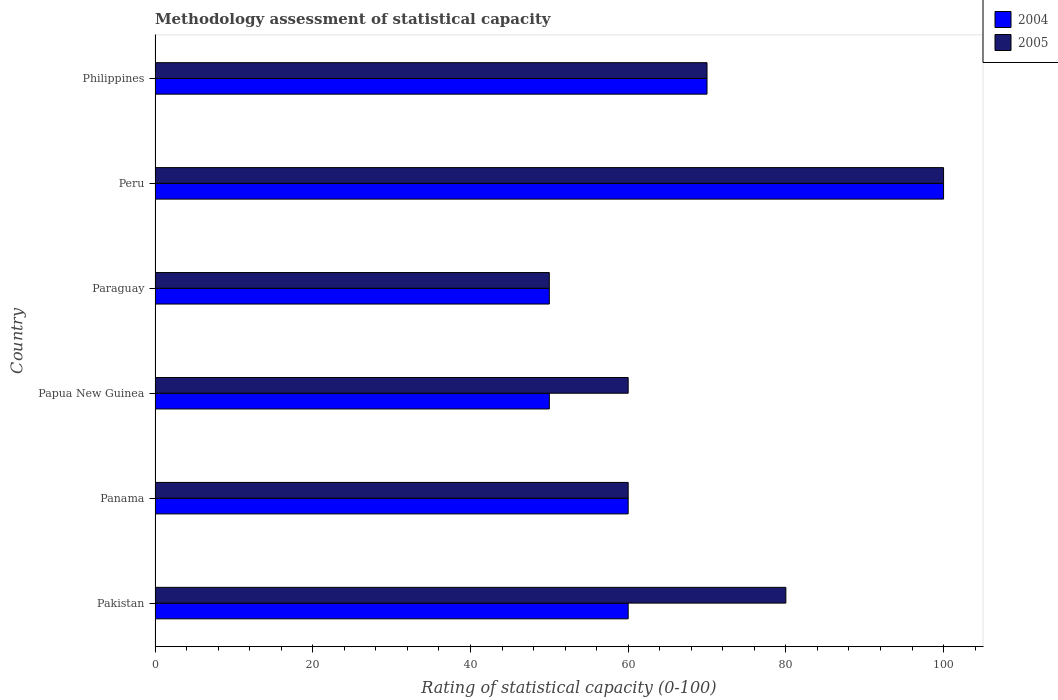Are the number of bars per tick equal to the number of legend labels?
Your answer should be very brief. Yes. What is the label of the 5th group of bars from the top?
Ensure brevity in your answer.  Panama. Across all countries, what is the minimum rating of statistical capacity in 2004?
Keep it short and to the point. 50. In which country was the rating of statistical capacity in 2005 minimum?
Offer a very short reply. Paraguay. What is the total rating of statistical capacity in 2004 in the graph?
Your response must be concise. 390. What is the difference between the rating of statistical capacity in 2004 in Pakistan and that in Papua New Guinea?
Give a very brief answer. 10. What is the difference between the rating of statistical capacity in 2005 in Panama and the rating of statistical capacity in 2004 in Pakistan?
Offer a very short reply. 0. What is the average rating of statistical capacity in 2005 per country?
Give a very brief answer. 70. In how many countries, is the rating of statistical capacity in 2004 greater than 36 ?
Offer a very short reply. 6. What is the ratio of the rating of statistical capacity in 2005 in Pakistan to that in Papua New Guinea?
Your answer should be very brief. 1.33. Is the rating of statistical capacity in 2004 in Panama less than that in Peru?
Offer a terse response. Yes. Is the difference between the rating of statistical capacity in 2004 in Panama and Papua New Guinea greater than the difference between the rating of statistical capacity in 2005 in Panama and Papua New Guinea?
Offer a terse response. Yes. What does the 1st bar from the top in Peru represents?
Make the answer very short. 2005. Are all the bars in the graph horizontal?
Keep it short and to the point. Yes. How many countries are there in the graph?
Ensure brevity in your answer.  6. Are the values on the major ticks of X-axis written in scientific E-notation?
Your answer should be very brief. No. How are the legend labels stacked?
Give a very brief answer. Vertical. What is the title of the graph?
Give a very brief answer. Methodology assessment of statistical capacity. Does "2003" appear as one of the legend labels in the graph?
Your answer should be compact. No. What is the label or title of the X-axis?
Offer a terse response. Rating of statistical capacity (0-100). What is the Rating of statistical capacity (0-100) of 2005 in Pakistan?
Ensure brevity in your answer.  80. What is the Rating of statistical capacity (0-100) of 2005 in Panama?
Offer a very short reply. 60. What is the Rating of statistical capacity (0-100) of 2005 in Papua New Guinea?
Provide a succinct answer. 60. What is the Rating of statistical capacity (0-100) in 2004 in Paraguay?
Keep it short and to the point. 50. What is the Rating of statistical capacity (0-100) in 2005 in Paraguay?
Your response must be concise. 50. What is the Rating of statistical capacity (0-100) in 2005 in Peru?
Your answer should be very brief. 100. What is the Rating of statistical capacity (0-100) of 2005 in Philippines?
Provide a succinct answer. 70. Across all countries, what is the maximum Rating of statistical capacity (0-100) in 2004?
Provide a succinct answer. 100. Across all countries, what is the maximum Rating of statistical capacity (0-100) of 2005?
Ensure brevity in your answer.  100. Across all countries, what is the minimum Rating of statistical capacity (0-100) of 2004?
Make the answer very short. 50. What is the total Rating of statistical capacity (0-100) in 2004 in the graph?
Your answer should be compact. 390. What is the total Rating of statistical capacity (0-100) in 2005 in the graph?
Keep it short and to the point. 420. What is the difference between the Rating of statistical capacity (0-100) of 2005 in Pakistan and that in Paraguay?
Offer a very short reply. 30. What is the difference between the Rating of statistical capacity (0-100) of 2005 in Pakistan and that in Peru?
Provide a succinct answer. -20. What is the difference between the Rating of statistical capacity (0-100) of 2004 in Pakistan and that in Philippines?
Give a very brief answer. -10. What is the difference between the Rating of statistical capacity (0-100) of 2005 in Pakistan and that in Philippines?
Ensure brevity in your answer.  10. What is the difference between the Rating of statistical capacity (0-100) of 2004 in Panama and that in Papua New Guinea?
Provide a succinct answer. 10. What is the difference between the Rating of statistical capacity (0-100) in 2004 in Panama and that in Peru?
Offer a very short reply. -40. What is the difference between the Rating of statistical capacity (0-100) of 2004 in Panama and that in Philippines?
Your response must be concise. -10. What is the difference between the Rating of statistical capacity (0-100) of 2005 in Panama and that in Philippines?
Provide a succinct answer. -10. What is the difference between the Rating of statistical capacity (0-100) in 2005 in Papua New Guinea and that in Paraguay?
Ensure brevity in your answer.  10. What is the difference between the Rating of statistical capacity (0-100) in 2004 in Papua New Guinea and that in Peru?
Give a very brief answer. -50. What is the difference between the Rating of statistical capacity (0-100) in 2005 in Papua New Guinea and that in Peru?
Your answer should be compact. -40. What is the difference between the Rating of statistical capacity (0-100) in 2004 in Papua New Guinea and that in Philippines?
Provide a short and direct response. -20. What is the difference between the Rating of statistical capacity (0-100) of 2004 in Paraguay and that in Peru?
Give a very brief answer. -50. What is the difference between the Rating of statistical capacity (0-100) of 2004 in Peru and that in Philippines?
Provide a succinct answer. 30. What is the difference between the Rating of statistical capacity (0-100) of 2005 in Peru and that in Philippines?
Make the answer very short. 30. What is the difference between the Rating of statistical capacity (0-100) in 2004 in Pakistan and the Rating of statistical capacity (0-100) in 2005 in Panama?
Keep it short and to the point. 0. What is the difference between the Rating of statistical capacity (0-100) in 2004 in Pakistan and the Rating of statistical capacity (0-100) in 2005 in Paraguay?
Your answer should be compact. 10. What is the difference between the Rating of statistical capacity (0-100) in 2004 in Pakistan and the Rating of statistical capacity (0-100) in 2005 in Peru?
Ensure brevity in your answer.  -40. What is the difference between the Rating of statistical capacity (0-100) of 2004 in Panama and the Rating of statistical capacity (0-100) of 2005 in Papua New Guinea?
Make the answer very short. 0. What is the difference between the Rating of statistical capacity (0-100) in 2004 in Papua New Guinea and the Rating of statistical capacity (0-100) in 2005 in Paraguay?
Give a very brief answer. 0. What is the difference between the Rating of statistical capacity (0-100) of 2004 in Papua New Guinea and the Rating of statistical capacity (0-100) of 2005 in Peru?
Ensure brevity in your answer.  -50. What is the difference between the Rating of statistical capacity (0-100) of 2004 in Papua New Guinea and the Rating of statistical capacity (0-100) of 2005 in Philippines?
Provide a short and direct response. -20. What is the difference between the Rating of statistical capacity (0-100) of 2004 in Paraguay and the Rating of statistical capacity (0-100) of 2005 in Peru?
Make the answer very short. -50. What is the difference between the Rating of statistical capacity (0-100) in 2004 in Paraguay and the Rating of statistical capacity (0-100) in 2005 in Philippines?
Offer a terse response. -20. What is the difference between the Rating of statistical capacity (0-100) in 2004 and Rating of statistical capacity (0-100) in 2005 in Pakistan?
Provide a short and direct response. -20. What is the difference between the Rating of statistical capacity (0-100) in 2004 and Rating of statistical capacity (0-100) in 2005 in Panama?
Provide a short and direct response. 0. What is the ratio of the Rating of statistical capacity (0-100) in 2004 in Pakistan to that in Panama?
Provide a succinct answer. 1. What is the ratio of the Rating of statistical capacity (0-100) in 2005 in Pakistan to that in Panama?
Ensure brevity in your answer.  1.33. What is the ratio of the Rating of statistical capacity (0-100) in 2005 in Pakistan to that in Papua New Guinea?
Your answer should be compact. 1.33. What is the ratio of the Rating of statistical capacity (0-100) in 2004 in Pakistan to that in Paraguay?
Provide a short and direct response. 1.2. What is the ratio of the Rating of statistical capacity (0-100) of 2005 in Pakistan to that in Peru?
Give a very brief answer. 0.8. What is the ratio of the Rating of statistical capacity (0-100) in 2005 in Panama to that in Papua New Guinea?
Provide a short and direct response. 1. What is the ratio of the Rating of statistical capacity (0-100) of 2005 in Panama to that in Paraguay?
Provide a short and direct response. 1.2. What is the ratio of the Rating of statistical capacity (0-100) in 2004 in Panama to that in Peru?
Offer a very short reply. 0.6. What is the ratio of the Rating of statistical capacity (0-100) in 2005 in Panama to that in Peru?
Provide a short and direct response. 0.6. What is the ratio of the Rating of statistical capacity (0-100) in 2005 in Panama to that in Philippines?
Keep it short and to the point. 0.86. What is the ratio of the Rating of statistical capacity (0-100) of 2004 in Papua New Guinea to that in Paraguay?
Your answer should be very brief. 1. What is the ratio of the Rating of statistical capacity (0-100) of 2005 in Papua New Guinea to that in Paraguay?
Offer a terse response. 1.2. What is the ratio of the Rating of statistical capacity (0-100) in 2005 in Papua New Guinea to that in Philippines?
Your answer should be compact. 0.86. What is the ratio of the Rating of statistical capacity (0-100) of 2004 in Paraguay to that in Peru?
Your answer should be compact. 0.5. What is the ratio of the Rating of statistical capacity (0-100) of 2005 in Paraguay to that in Peru?
Offer a very short reply. 0.5. What is the ratio of the Rating of statistical capacity (0-100) in 2004 in Paraguay to that in Philippines?
Keep it short and to the point. 0.71. What is the ratio of the Rating of statistical capacity (0-100) of 2004 in Peru to that in Philippines?
Keep it short and to the point. 1.43. What is the ratio of the Rating of statistical capacity (0-100) in 2005 in Peru to that in Philippines?
Give a very brief answer. 1.43. What is the difference between the highest and the second highest Rating of statistical capacity (0-100) in 2004?
Keep it short and to the point. 30. What is the difference between the highest and the second highest Rating of statistical capacity (0-100) of 2005?
Provide a succinct answer. 20. What is the difference between the highest and the lowest Rating of statistical capacity (0-100) of 2004?
Make the answer very short. 50. What is the difference between the highest and the lowest Rating of statistical capacity (0-100) of 2005?
Provide a short and direct response. 50. 